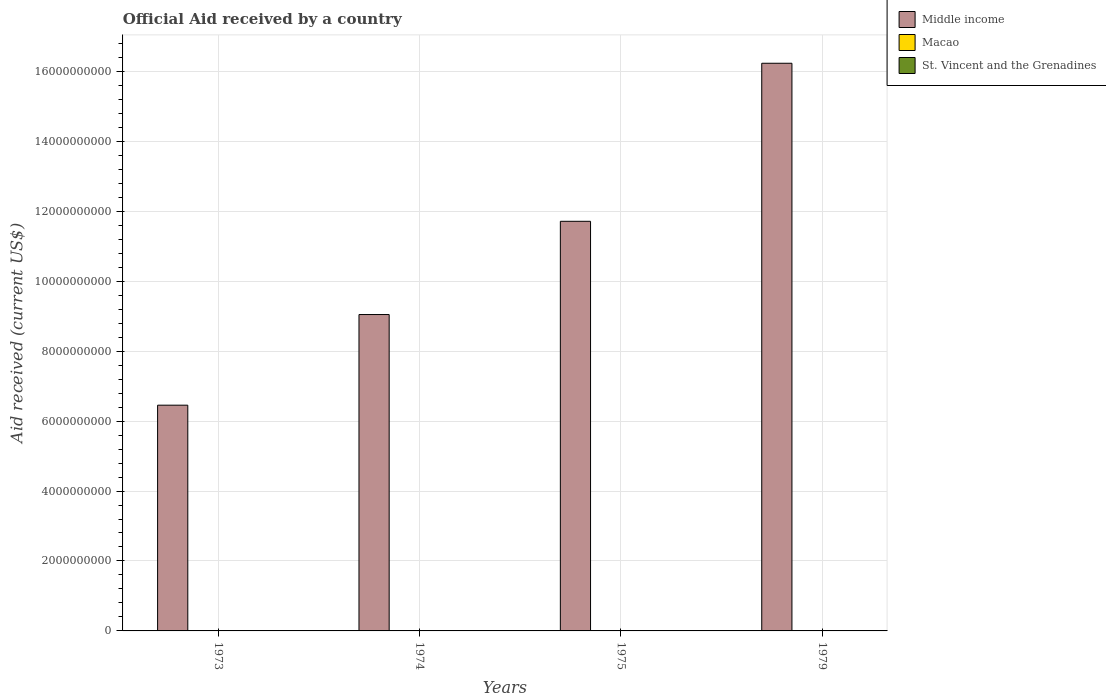How many different coloured bars are there?
Ensure brevity in your answer.  3. How many groups of bars are there?
Ensure brevity in your answer.  4. Are the number of bars per tick equal to the number of legend labels?
Offer a terse response. Yes. How many bars are there on the 1st tick from the right?
Offer a terse response. 3. What is the label of the 4th group of bars from the left?
Offer a very short reply. 1979. What is the net official aid received in Middle income in 1973?
Offer a very short reply. 6.45e+09. Across all years, what is the maximum net official aid received in Middle income?
Make the answer very short. 1.62e+1. In which year was the net official aid received in Middle income maximum?
Provide a short and direct response. 1979. What is the difference between the net official aid received in Macao in 1974 and that in 1979?
Give a very brief answer. 10000. What is the difference between the net official aid received in Macao in 1974 and the net official aid received in St. Vincent and the Grenadines in 1979?
Provide a succinct answer. -5.67e+06. What is the average net official aid received in Middle income per year?
Offer a very short reply. 1.09e+1. What is the difference between the highest and the second highest net official aid received in Middle income?
Your answer should be very brief. 4.52e+09. What is the difference between the highest and the lowest net official aid received in St. Vincent and the Grenadines?
Make the answer very short. 5.86e+06. In how many years, is the net official aid received in Macao greater than the average net official aid received in Macao taken over all years?
Your response must be concise. 1. What does the 3rd bar from the left in 1975 represents?
Make the answer very short. St. Vincent and the Grenadines. Is it the case that in every year, the sum of the net official aid received in Macao and net official aid received in St. Vincent and the Grenadines is greater than the net official aid received in Middle income?
Keep it short and to the point. No. How many years are there in the graph?
Make the answer very short. 4. Are the values on the major ticks of Y-axis written in scientific E-notation?
Ensure brevity in your answer.  No. Does the graph contain any zero values?
Your response must be concise. No. Does the graph contain grids?
Make the answer very short. Yes. What is the title of the graph?
Your response must be concise. Official Aid received by a country. Does "East Asia (developing only)" appear as one of the legend labels in the graph?
Provide a succinct answer. No. What is the label or title of the Y-axis?
Offer a very short reply. Aid received (current US$). What is the Aid received (current US$) of Middle income in 1973?
Offer a terse response. 6.45e+09. What is the Aid received (current US$) of St. Vincent and the Grenadines in 1973?
Offer a terse response. 1.20e+05. What is the Aid received (current US$) in Middle income in 1974?
Your response must be concise. 9.05e+09. What is the Aid received (current US$) of Macao in 1974?
Provide a short and direct response. 3.00e+04. What is the Aid received (current US$) of St. Vincent and the Grenadines in 1974?
Provide a succinct answer. 3.66e+06. What is the Aid received (current US$) in Middle income in 1975?
Give a very brief answer. 1.17e+1. What is the Aid received (current US$) of Macao in 1975?
Provide a short and direct response. 2.00e+04. What is the Aid received (current US$) in St. Vincent and the Grenadines in 1975?
Your answer should be compact. 5.98e+06. What is the Aid received (current US$) of Middle income in 1979?
Give a very brief answer. 1.62e+1. What is the Aid received (current US$) in St. Vincent and the Grenadines in 1979?
Offer a terse response. 5.70e+06. Across all years, what is the maximum Aid received (current US$) of Middle income?
Ensure brevity in your answer.  1.62e+1. Across all years, what is the maximum Aid received (current US$) of St. Vincent and the Grenadines?
Offer a terse response. 5.98e+06. Across all years, what is the minimum Aid received (current US$) in Middle income?
Keep it short and to the point. 6.45e+09. What is the total Aid received (current US$) in Middle income in the graph?
Provide a succinct answer. 4.34e+1. What is the total Aid received (current US$) in St. Vincent and the Grenadines in the graph?
Provide a short and direct response. 1.55e+07. What is the difference between the Aid received (current US$) of Middle income in 1973 and that in 1974?
Ensure brevity in your answer.  -2.59e+09. What is the difference between the Aid received (current US$) in Macao in 1973 and that in 1974?
Provide a succinct answer. 9.00e+04. What is the difference between the Aid received (current US$) in St. Vincent and the Grenadines in 1973 and that in 1974?
Give a very brief answer. -3.54e+06. What is the difference between the Aid received (current US$) of Middle income in 1973 and that in 1975?
Offer a terse response. -5.26e+09. What is the difference between the Aid received (current US$) of St. Vincent and the Grenadines in 1973 and that in 1975?
Ensure brevity in your answer.  -5.86e+06. What is the difference between the Aid received (current US$) in Middle income in 1973 and that in 1979?
Your answer should be compact. -9.78e+09. What is the difference between the Aid received (current US$) of Macao in 1973 and that in 1979?
Your answer should be compact. 1.00e+05. What is the difference between the Aid received (current US$) of St. Vincent and the Grenadines in 1973 and that in 1979?
Your answer should be very brief. -5.58e+06. What is the difference between the Aid received (current US$) of Middle income in 1974 and that in 1975?
Give a very brief answer. -2.67e+09. What is the difference between the Aid received (current US$) of St. Vincent and the Grenadines in 1974 and that in 1975?
Your answer should be compact. -2.32e+06. What is the difference between the Aid received (current US$) in Middle income in 1974 and that in 1979?
Offer a terse response. -7.18e+09. What is the difference between the Aid received (current US$) in Macao in 1974 and that in 1979?
Make the answer very short. 10000. What is the difference between the Aid received (current US$) in St. Vincent and the Grenadines in 1974 and that in 1979?
Keep it short and to the point. -2.04e+06. What is the difference between the Aid received (current US$) of Middle income in 1975 and that in 1979?
Ensure brevity in your answer.  -4.52e+09. What is the difference between the Aid received (current US$) in Macao in 1975 and that in 1979?
Provide a short and direct response. 0. What is the difference between the Aid received (current US$) of Middle income in 1973 and the Aid received (current US$) of Macao in 1974?
Provide a succinct answer. 6.45e+09. What is the difference between the Aid received (current US$) of Middle income in 1973 and the Aid received (current US$) of St. Vincent and the Grenadines in 1974?
Your response must be concise. 6.45e+09. What is the difference between the Aid received (current US$) in Macao in 1973 and the Aid received (current US$) in St. Vincent and the Grenadines in 1974?
Provide a short and direct response. -3.54e+06. What is the difference between the Aid received (current US$) of Middle income in 1973 and the Aid received (current US$) of Macao in 1975?
Your response must be concise. 6.45e+09. What is the difference between the Aid received (current US$) of Middle income in 1973 and the Aid received (current US$) of St. Vincent and the Grenadines in 1975?
Provide a short and direct response. 6.45e+09. What is the difference between the Aid received (current US$) of Macao in 1973 and the Aid received (current US$) of St. Vincent and the Grenadines in 1975?
Offer a terse response. -5.86e+06. What is the difference between the Aid received (current US$) of Middle income in 1973 and the Aid received (current US$) of Macao in 1979?
Keep it short and to the point. 6.45e+09. What is the difference between the Aid received (current US$) in Middle income in 1973 and the Aid received (current US$) in St. Vincent and the Grenadines in 1979?
Your answer should be very brief. 6.45e+09. What is the difference between the Aid received (current US$) of Macao in 1973 and the Aid received (current US$) of St. Vincent and the Grenadines in 1979?
Ensure brevity in your answer.  -5.58e+06. What is the difference between the Aid received (current US$) in Middle income in 1974 and the Aid received (current US$) in Macao in 1975?
Ensure brevity in your answer.  9.05e+09. What is the difference between the Aid received (current US$) in Middle income in 1974 and the Aid received (current US$) in St. Vincent and the Grenadines in 1975?
Keep it short and to the point. 9.04e+09. What is the difference between the Aid received (current US$) in Macao in 1974 and the Aid received (current US$) in St. Vincent and the Grenadines in 1975?
Your response must be concise. -5.95e+06. What is the difference between the Aid received (current US$) of Middle income in 1974 and the Aid received (current US$) of Macao in 1979?
Give a very brief answer. 9.05e+09. What is the difference between the Aid received (current US$) in Middle income in 1974 and the Aid received (current US$) in St. Vincent and the Grenadines in 1979?
Provide a short and direct response. 9.04e+09. What is the difference between the Aid received (current US$) of Macao in 1974 and the Aid received (current US$) of St. Vincent and the Grenadines in 1979?
Give a very brief answer. -5.67e+06. What is the difference between the Aid received (current US$) in Middle income in 1975 and the Aid received (current US$) in Macao in 1979?
Offer a terse response. 1.17e+1. What is the difference between the Aid received (current US$) of Middle income in 1975 and the Aid received (current US$) of St. Vincent and the Grenadines in 1979?
Your answer should be very brief. 1.17e+1. What is the difference between the Aid received (current US$) of Macao in 1975 and the Aid received (current US$) of St. Vincent and the Grenadines in 1979?
Your answer should be very brief. -5.68e+06. What is the average Aid received (current US$) of Middle income per year?
Your answer should be very brief. 1.09e+1. What is the average Aid received (current US$) of Macao per year?
Make the answer very short. 4.75e+04. What is the average Aid received (current US$) in St. Vincent and the Grenadines per year?
Your answer should be compact. 3.86e+06. In the year 1973, what is the difference between the Aid received (current US$) of Middle income and Aid received (current US$) of Macao?
Provide a succinct answer. 6.45e+09. In the year 1973, what is the difference between the Aid received (current US$) in Middle income and Aid received (current US$) in St. Vincent and the Grenadines?
Your response must be concise. 6.45e+09. In the year 1974, what is the difference between the Aid received (current US$) of Middle income and Aid received (current US$) of Macao?
Provide a short and direct response. 9.05e+09. In the year 1974, what is the difference between the Aid received (current US$) in Middle income and Aid received (current US$) in St. Vincent and the Grenadines?
Make the answer very short. 9.04e+09. In the year 1974, what is the difference between the Aid received (current US$) in Macao and Aid received (current US$) in St. Vincent and the Grenadines?
Your answer should be compact. -3.63e+06. In the year 1975, what is the difference between the Aid received (current US$) in Middle income and Aid received (current US$) in Macao?
Provide a succinct answer. 1.17e+1. In the year 1975, what is the difference between the Aid received (current US$) of Middle income and Aid received (current US$) of St. Vincent and the Grenadines?
Your answer should be compact. 1.17e+1. In the year 1975, what is the difference between the Aid received (current US$) in Macao and Aid received (current US$) in St. Vincent and the Grenadines?
Offer a terse response. -5.96e+06. In the year 1979, what is the difference between the Aid received (current US$) of Middle income and Aid received (current US$) of Macao?
Your answer should be very brief. 1.62e+1. In the year 1979, what is the difference between the Aid received (current US$) in Middle income and Aid received (current US$) in St. Vincent and the Grenadines?
Your response must be concise. 1.62e+1. In the year 1979, what is the difference between the Aid received (current US$) in Macao and Aid received (current US$) in St. Vincent and the Grenadines?
Give a very brief answer. -5.68e+06. What is the ratio of the Aid received (current US$) in Middle income in 1973 to that in 1974?
Give a very brief answer. 0.71. What is the ratio of the Aid received (current US$) in St. Vincent and the Grenadines in 1973 to that in 1974?
Your answer should be very brief. 0.03. What is the ratio of the Aid received (current US$) of Middle income in 1973 to that in 1975?
Make the answer very short. 0.55. What is the ratio of the Aid received (current US$) in Macao in 1973 to that in 1975?
Your response must be concise. 6. What is the ratio of the Aid received (current US$) of St. Vincent and the Grenadines in 1973 to that in 1975?
Offer a very short reply. 0.02. What is the ratio of the Aid received (current US$) in Middle income in 1973 to that in 1979?
Your response must be concise. 0.4. What is the ratio of the Aid received (current US$) of Macao in 1973 to that in 1979?
Your answer should be very brief. 6. What is the ratio of the Aid received (current US$) in St. Vincent and the Grenadines in 1973 to that in 1979?
Make the answer very short. 0.02. What is the ratio of the Aid received (current US$) in Middle income in 1974 to that in 1975?
Your answer should be compact. 0.77. What is the ratio of the Aid received (current US$) of St. Vincent and the Grenadines in 1974 to that in 1975?
Give a very brief answer. 0.61. What is the ratio of the Aid received (current US$) of Middle income in 1974 to that in 1979?
Offer a very short reply. 0.56. What is the ratio of the Aid received (current US$) of Macao in 1974 to that in 1979?
Offer a very short reply. 1.5. What is the ratio of the Aid received (current US$) in St. Vincent and the Grenadines in 1974 to that in 1979?
Give a very brief answer. 0.64. What is the ratio of the Aid received (current US$) in Middle income in 1975 to that in 1979?
Provide a short and direct response. 0.72. What is the ratio of the Aid received (current US$) in St. Vincent and the Grenadines in 1975 to that in 1979?
Ensure brevity in your answer.  1.05. What is the difference between the highest and the second highest Aid received (current US$) of Middle income?
Keep it short and to the point. 4.52e+09. What is the difference between the highest and the second highest Aid received (current US$) of St. Vincent and the Grenadines?
Your response must be concise. 2.80e+05. What is the difference between the highest and the lowest Aid received (current US$) of Middle income?
Keep it short and to the point. 9.78e+09. What is the difference between the highest and the lowest Aid received (current US$) in St. Vincent and the Grenadines?
Provide a succinct answer. 5.86e+06. 